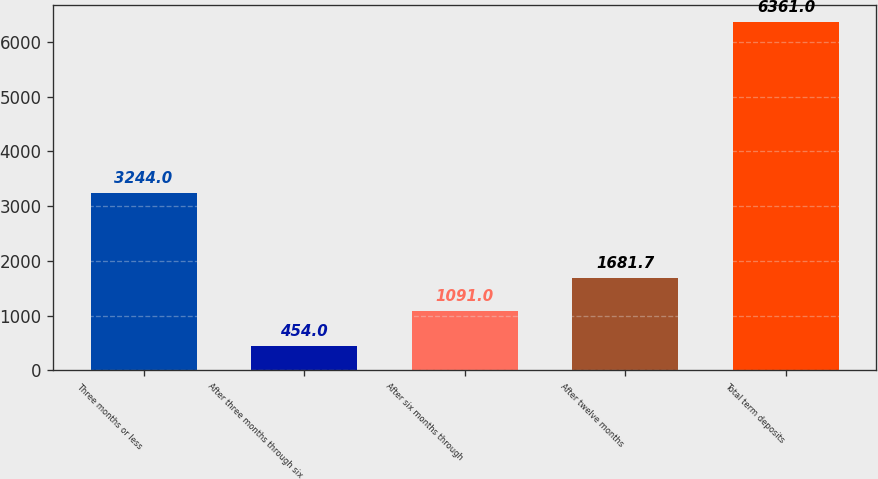Convert chart. <chart><loc_0><loc_0><loc_500><loc_500><bar_chart><fcel>Three months or less<fcel>After three months through six<fcel>After six months through<fcel>After twelve months<fcel>Total term deposits<nl><fcel>3244<fcel>454<fcel>1091<fcel>1681.7<fcel>6361<nl></chart> 